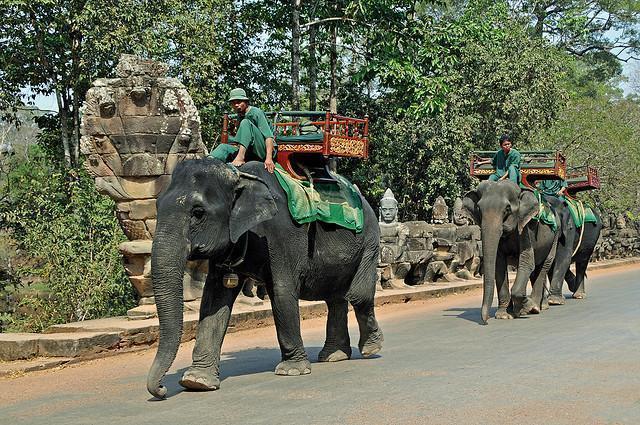Which country is famous for elephants?
Make your selection from the four choices given to correctly answer the question.
Options: Norway, sydney, thailand, dutch. Thailand. 